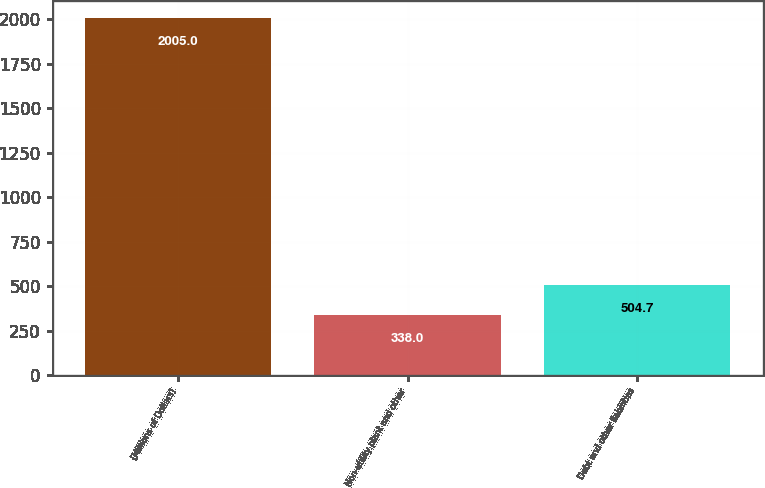Convert chart to OTSL. <chart><loc_0><loc_0><loc_500><loc_500><bar_chart><fcel>(Millions of Dollars)<fcel>Non-utility plant and other<fcel>Debt and other liabilities<nl><fcel>2005<fcel>338<fcel>504.7<nl></chart> 